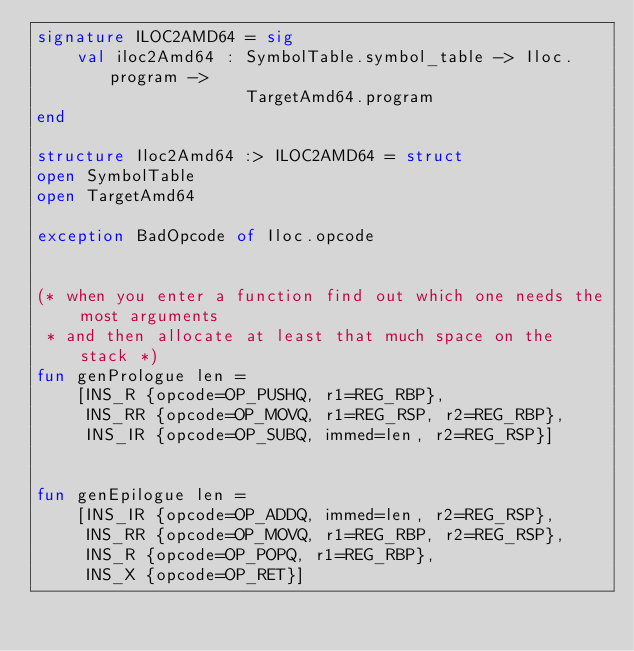Convert code to text. <code><loc_0><loc_0><loc_500><loc_500><_SML_>signature ILOC2AMD64 = sig
    val iloc2Amd64 : SymbolTable.symbol_table -> Iloc.program ->
                     TargetAmd64.program
end

structure Iloc2Amd64 :> ILOC2AMD64 = struct
open SymbolTable
open TargetAmd64

exception BadOpcode of Iloc.opcode


(* when you enter a function find out which one needs the most arguments
 * and then allocate at least that much space on the stack *)
fun genPrologue len =
    [INS_R {opcode=OP_PUSHQ, r1=REG_RBP},
     INS_RR {opcode=OP_MOVQ, r1=REG_RSP, r2=REG_RBP},
     INS_IR {opcode=OP_SUBQ, immed=len, r2=REG_RSP}]


fun genEpilogue len =
    [INS_IR {opcode=OP_ADDQ, immed=len, r2=REG_RSP},
     INS_RR {opcode=OP_MOVQ, r1=REG_RBP, r2=REG_RSP},
     INS_R {opcode=OP_POPQ, r1=REG_RBP},
     INS_X {opcode=OP_RET}]

</code> 